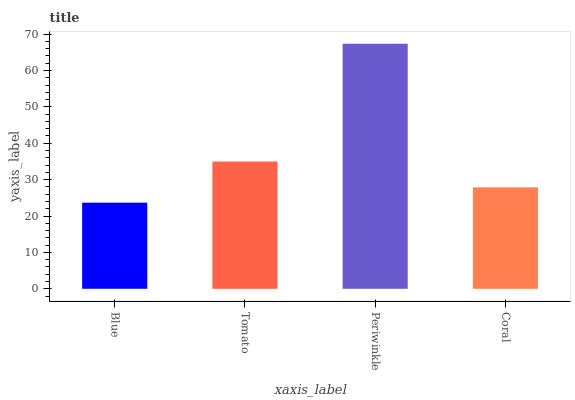Is Blue the minimum?
Answer yes or no. Yes. Is Periwinkle the maximum?
Answer yes or no. Yes. Is Tomato the minimum?
Answer yes or no. No. Is Tomato the maximum?
Answer yes or no. No. Is Tomato greater than Blue?
Answer yes or no. Yes. Is Blue less than Tomato?
Answer yes or no. Yes. Is Blue greater than Tomato?
Answer yes or no. No. Is Tomato less than Blue?
Answer yes or no. No. Is Tomato the high median?
Answer yes or no. Yes. Is Coral the low median?
Answer yes or no. Yes. Is Coral the high median?
Answer yes or no. No. Is Tomato the low median?
Answer yes or no. No. 